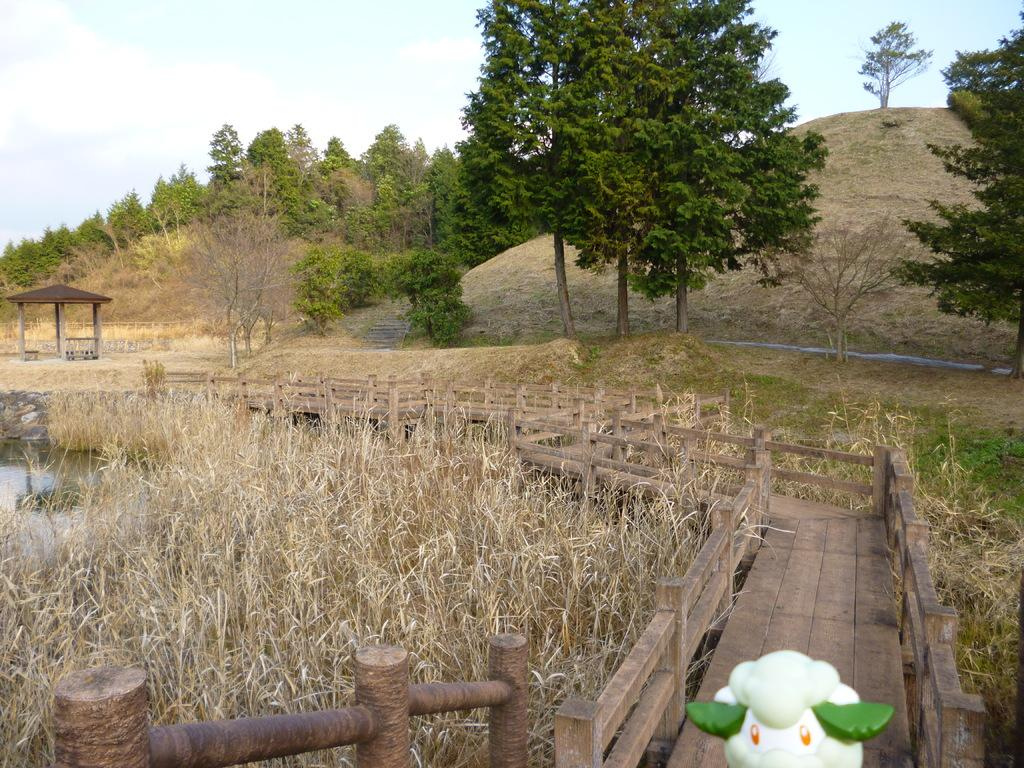What type of structure is present in the image? There is a walkway bridge in the image. What can be found on the ground near the bridge? There is a lawn with straw in the image. What type of landscape feature is visible in the image? There are hills visible in the image. What type of vegetation is present in the image? There are trees in the image. What is visible in the sky in the image? The sky is visible in the image, and clouds are present. Can you see a cub playing in the snow in the image? There is no cub or snow present in the image. How many worms can be seen crawling on the walkway bridge in the image? There are no worms visible on the walkway bridge in the image. 